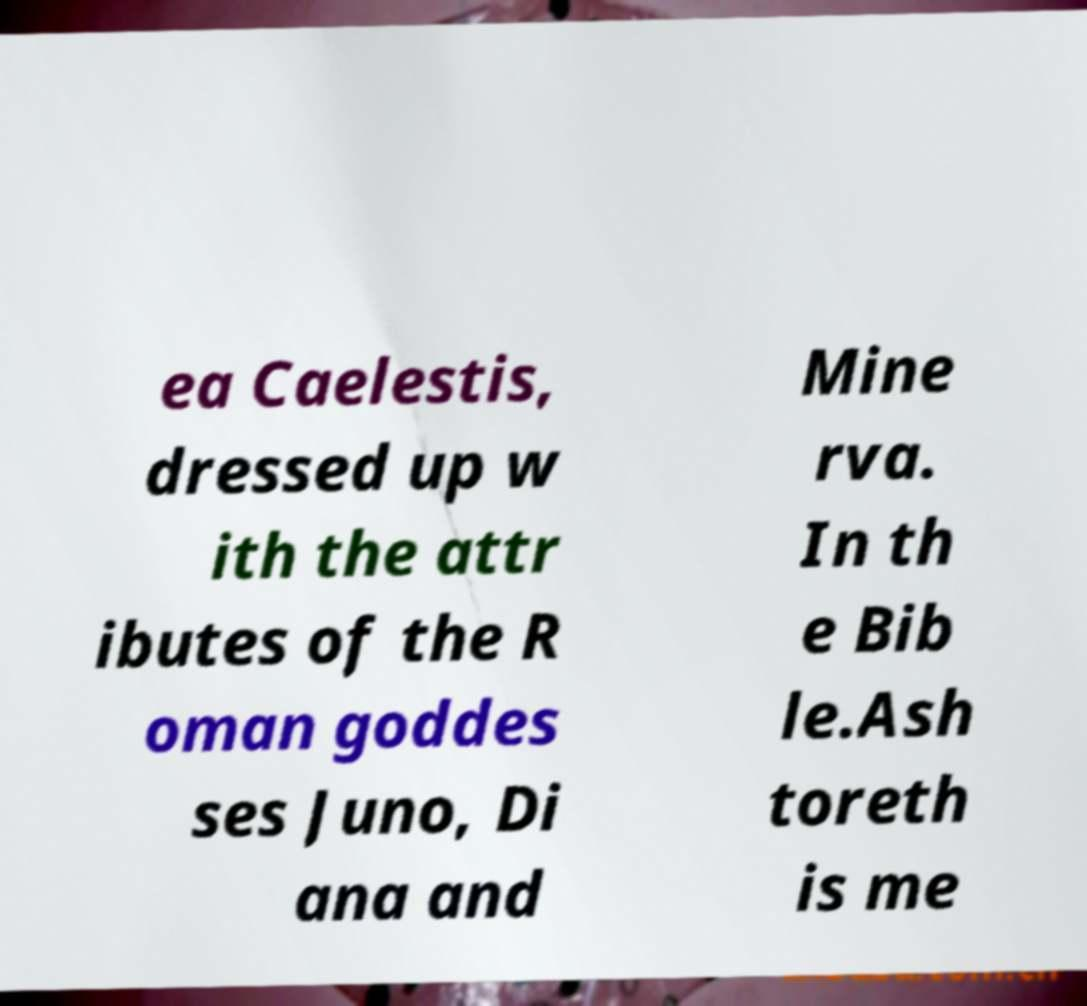What messages or text are displayed in this image? I need them in a readable, typed format. ea Caelestis, dressed up w ith the attr ibutes of the R oman goddes ses Juno, Di ana and Mine rva. In th e Bib le.Ash toreth is me 